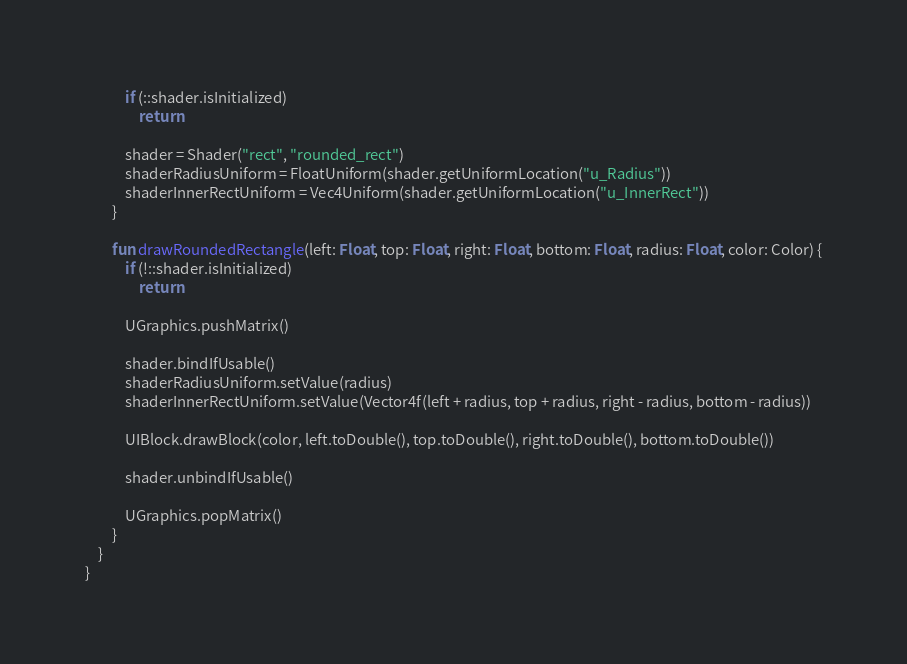<code> <loc_0><loc_0><loc_500><loc_500><_Kotlin_>            if (::shader.isInitialized)
                return

            shader = Shader("rect", "rounded_rect")
            shaderRadiusUniform = FloatUniform(shader.getUniformLocation("u_Radius"))
            shaderInnerRectUniform = Vec4Uniform(shader.getUniformLocation("u_InnerRect"))
        }

        fun drawRoundedRectangle(left: Float, top: Float, right: Float, bottom: Float, radius: Float, color: Color) {
            if (!::shader.isInitialized)
                return

            UGraphics.pushMatrix()

            shader.bindIfUsable()
            shaderRadiusUniform.setValue(radius)
            shaderInnerRectUniform.setValue(Vector4f(left + radius, top + radius, right - radius, bottom - radius))

            UIBlock.drawBlock(color, left.toDouble(), top.toDouble(), right.toDouble(), bottom.toDouble())

            shader.unbindIfUsable()

            UGraphics.popMatrix()
        }
    }
}
</code> 